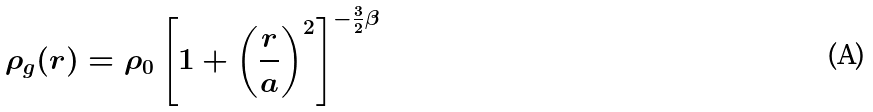<formula> <loc_0><loc_0><loc_500><loc_500>\rho _ { g } ( r ) = \rho _ { 0 } \left [ 1 + \left ( \frac { r } { a } \right ) ^ { 2 } \right ] ^ { - \frac { 3 } { 2 } \beta }</formula> 